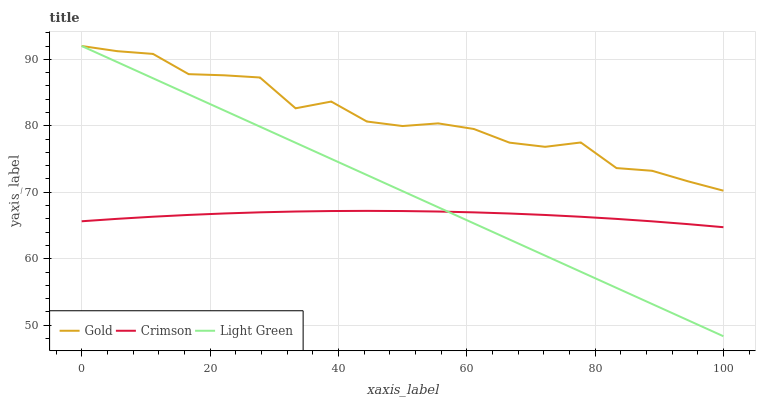Does Crimson have the minimum area under the curve?
Answer yes or no. Yes. Does Gold have the maximum area under the curve?
Answer yes or no. Yes. Does Light Green have the minimum area under the curve?
Answer yes or no. No. Does Light Green have the maximum area under the curve?
Answer yes or no. No. Is Light Green the smoothest?
Answer yes or no. Yes. Is Gold the roughest?
Answer yes or no. Yes. Is Gold the smoothest?
Answer yes or no. No. Is Light Green the roughest?
Answer yes or no. No. Does Gold have the lowest value?
Answer yes or no. No. Does Gold have the highest value?
Answer yes or no. Yes. Is Crimson less than Gold?
Answer yes or no. Yes. Is Gold greater than Crimson?
Answer yes or no. Yes. Does Crimson intersect Gold?
Answer yes or no. No. 